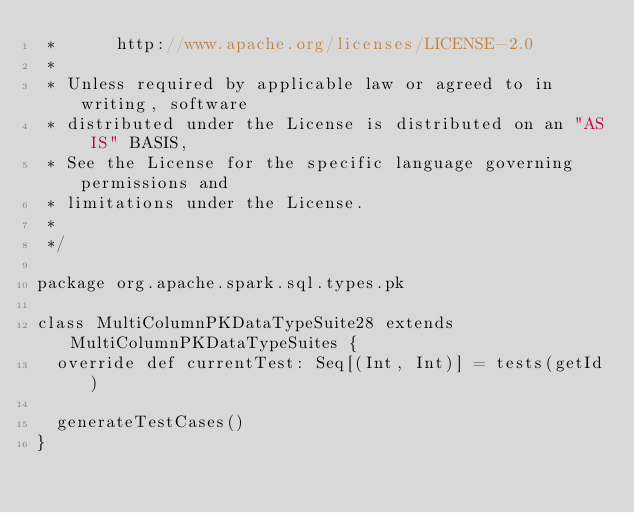<code> <loc_0><loc_0><loc_500><loc_500><_Scala_> *      http://www.apache.org/licenses/LICENSE-2.0
 *
 * Unless required by applicable law or agreed to in writing, software
 * distributed under the License is distributed on an "AS IS" BASIS,
 * See the License for the specific language governing permissions and
 * limitations under the License.
 *
 */

package org.apache.spark.sql.types.pk

class MultiColumnPKDataTypeSuite28 extends MultiColumnPKDataTypeSuites {
  override def currentTest: Seq[(Int, Int)] = tests(getId)

  generateTestCases()
}
</code> 